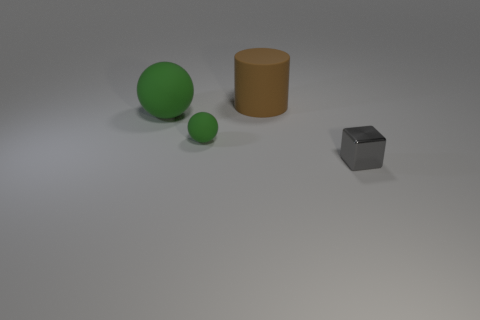Add 1 brown matte cylinders. How many objects exist? 5 Subtract all cylinders. How many objects are left? 3 Add 4 green matte things. How many green matte things exist? 6 Subtract 0 blue cylinders. How many objects are left? 4 Subtract all brown rubber objects. Subtract all big blue shiny objects. How many objects are left? 3 Add 4 rubber things. How many rubber things are left? 7 